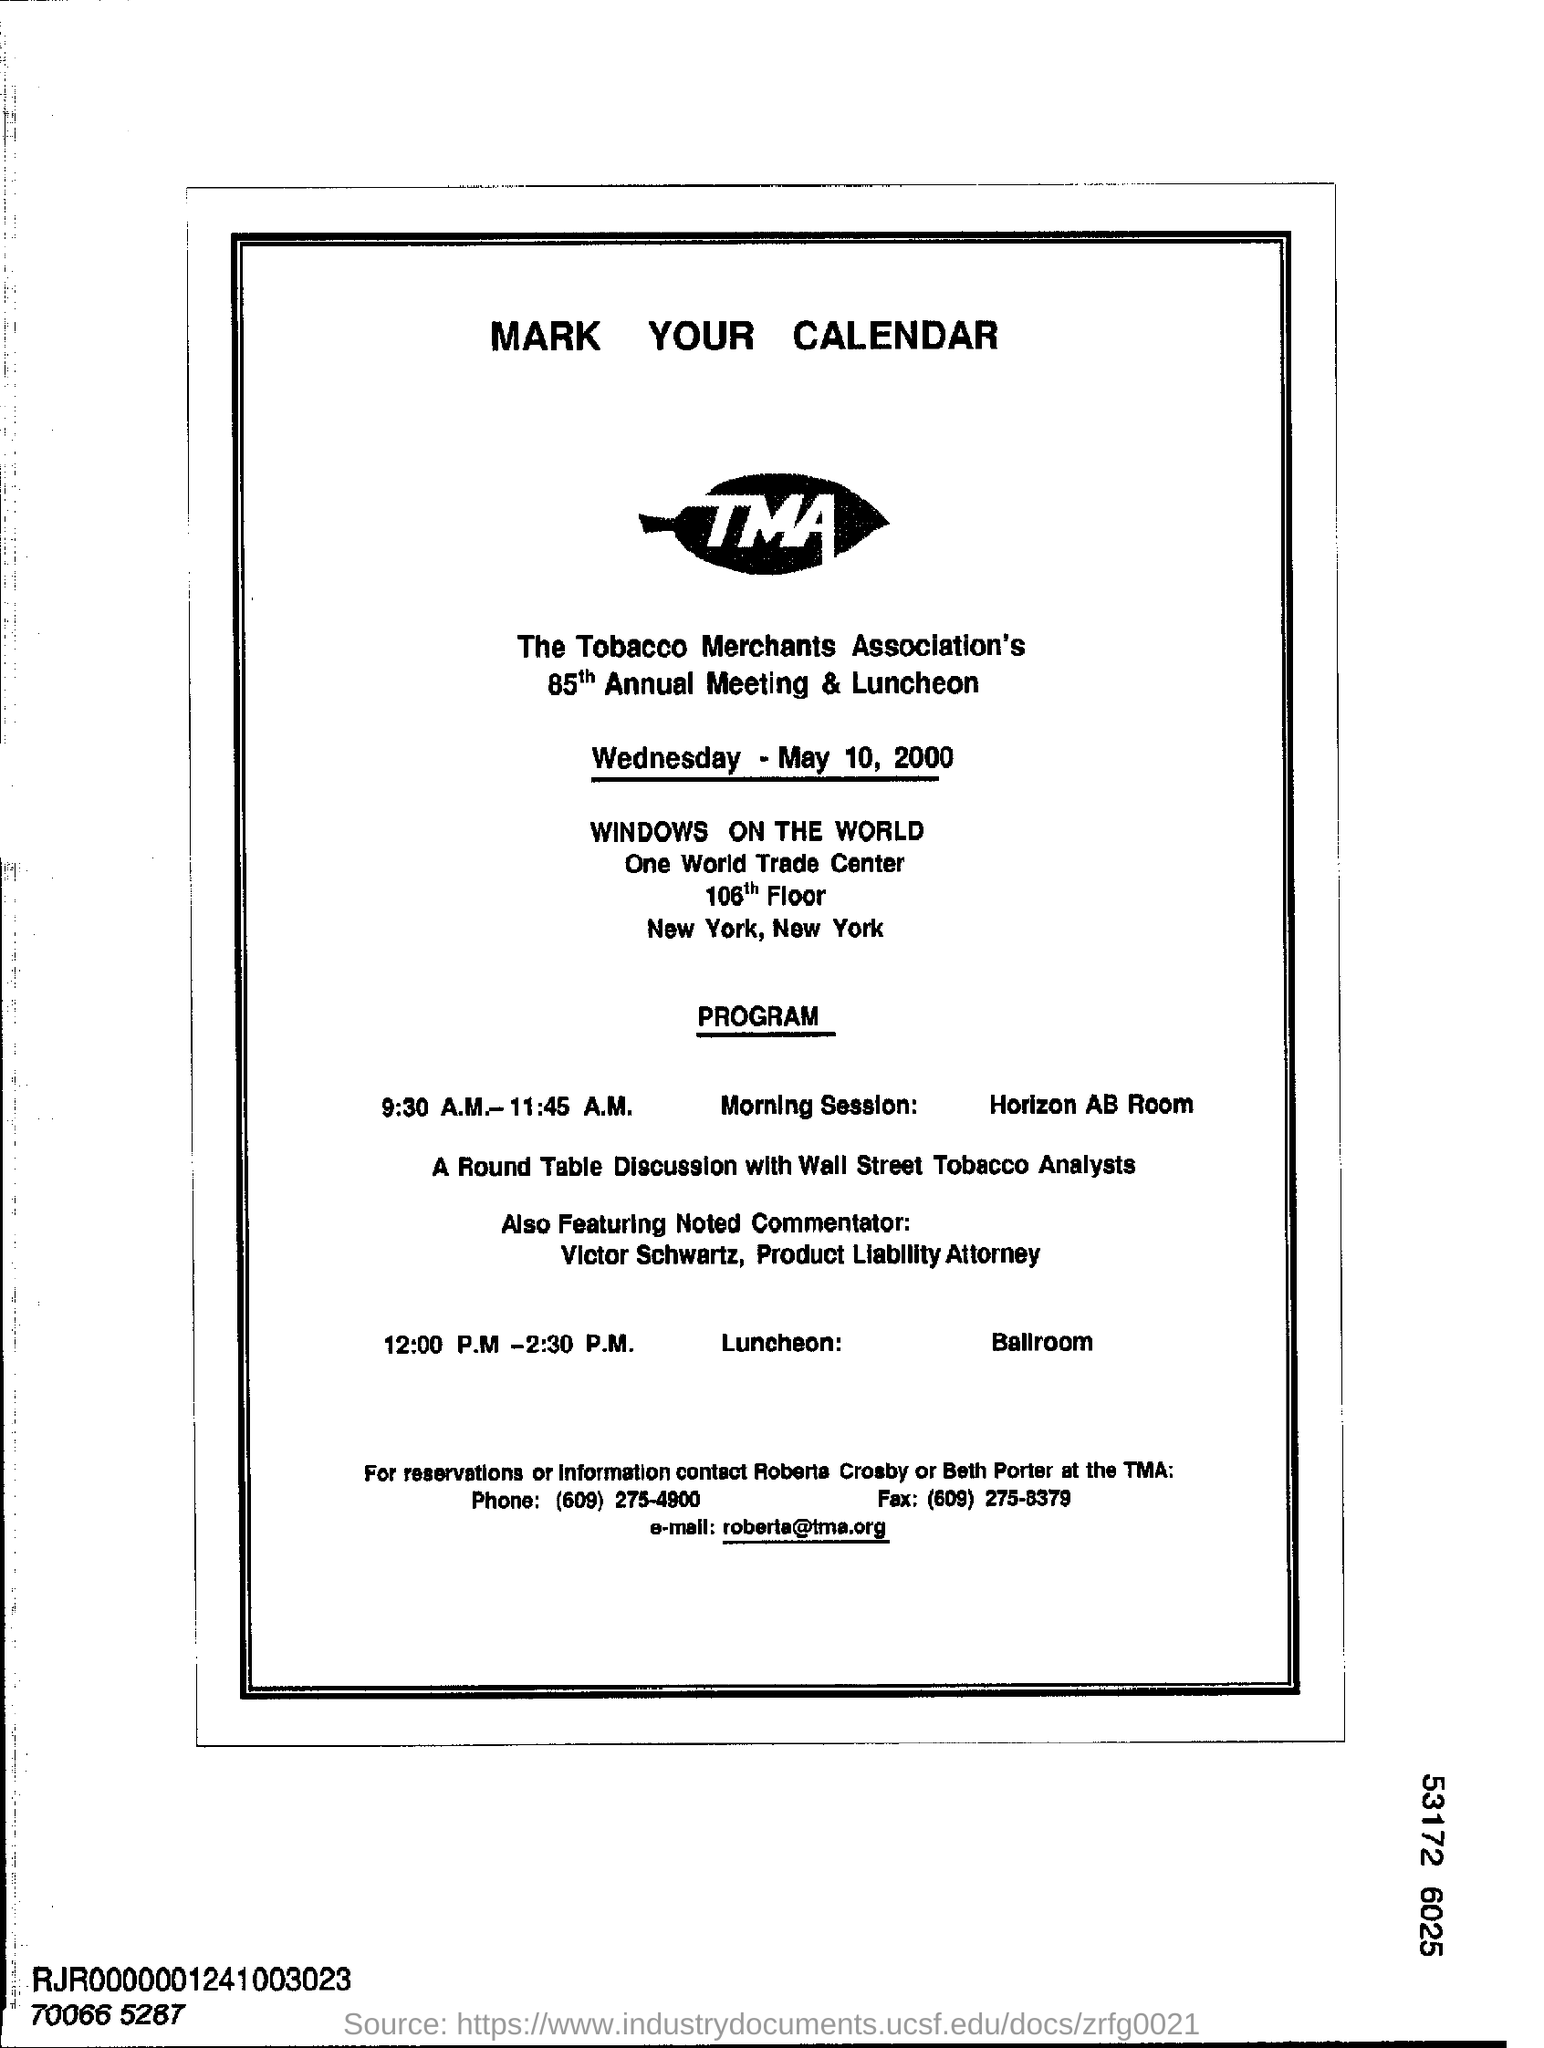Which association is hosting the 85th annual meeting and Luncheon at New York?
Provide a succinct answer. The Tobacco Merchants Association. When is the 85th Annual meeting is conducted?
Your answer should be compact. Wednesday - May 10 , 2000. Where the morning session of the 85th annual meeting is conducted?
Give a very brief answer. Horizon AB Room. When will the 85th annual meeting will end after luncheon ?
Your answer should be compact. 2.30 P.M. What is the email address mentioned at the bottom of the notice?
Your answer should be compact. Roberta@tma.org. What is the phone number?
Offer a very short reply. (609) 275-4900. 